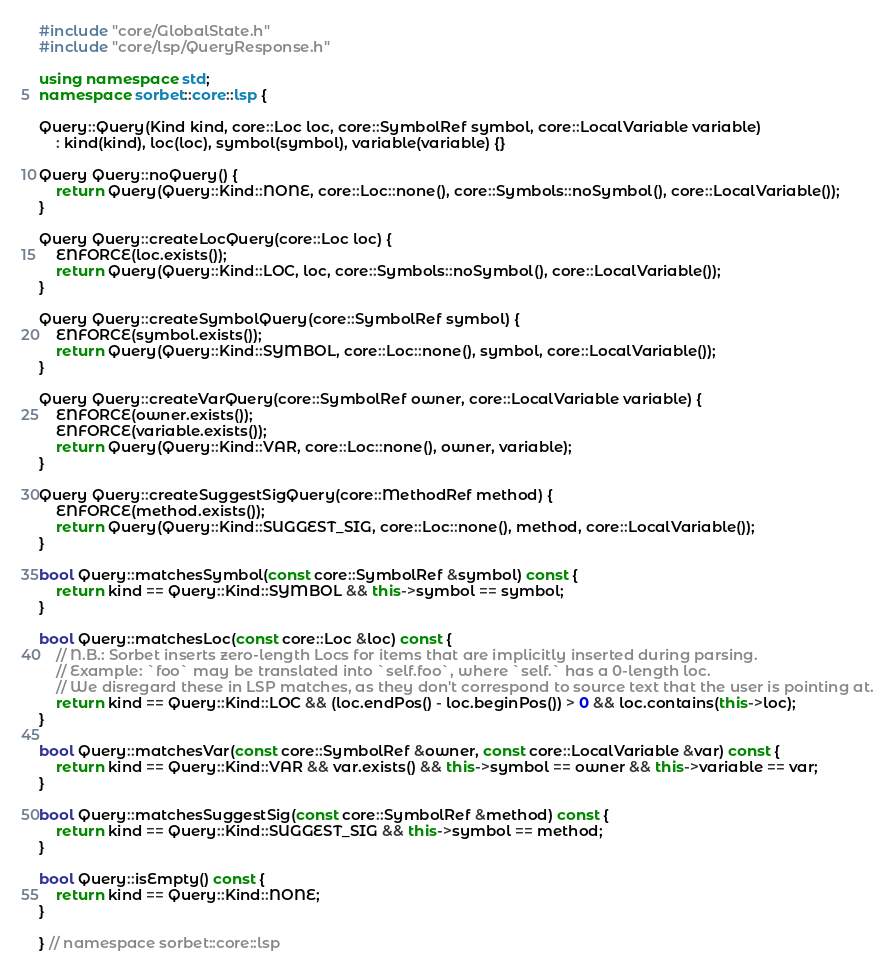Convert code to text. <code><loc_0><loc_0><loc_500><loc_500><_C++_>#include "core/GlobalState.h"
#include "core/lsp/QueryResponse.h"

using namespace std;
namespace sorbet::core::lsp {

Query::Query(Kind kind, core::Loc loc, core::SymbolRef symbol, core::LocalVariable variable)
    : kind(kind), loc(loc), symbol(symbol), variable(variable) {}

Query Query::noQuery() {
    return Query(Query::Kind::NONE, core::Loc::none(), core::Symbols::noSymbol(), core::LocalVariable());
}

Query Query::createLocQuery(core::Loc loc) {
    ENFORCE(loc.exists());
    return Query(Query::Kind::LOC, loc, core::Symbols::noSymbol(), core::LocalVariable());
}

Query Query::createSymbolQuery(core::SymbolRef symbol) {
    ENFORCE(symbol.exists());
    return Query(Query::Kind::SYMBOL, core::Loc::none(), symbol, core::LocalVariable());
}

Query Query::createVarQuery(core::SymbolRef owner, core::LocalVariable variable) {
    ENFORCE(owner.exists());
    ENFORCE(variable.exists());
    return Query(Query::Kind::VAR, core::Loc::none(), owner, variable);
}

Query Query::createSuggestSigQuery(core::MethodRef method) {
    ENFORCE(method.exists());
    return Query(Query::Kind::SUGGEST_SIG, core::Loc::none(), method, core::LocalVariable());
}

bool Query::matchesSymbol(const core::SymbolRef &symbol) const {
    return kind == Query::Kind::SYMBOL && this->symbol == symbol;
}

bool Query::matchesLoc(const core::Loc &loc) const {
    // N.B.: Sorbet inserts zero-length Locs for items that are implicitly inserted during parsing.
    // Example: `foo` may be translated into `self.foo`, where `self.` has a 0-length loc.
    // We disregard these in LSP matches, as they don't correspond to source text that the user is pointing at.
    return kind == Query::Kind::LOC && (loc.endPos() - loc.beginPos()) > 0 && loc.contains(this->loc);
}

bool Query::matchesVar(const core::SymbolRef &owner, const core::LocalVariable &var) const {
    return kind == Query::Kind::VAR && var.exists() && this->symbol == owner && this->variable == var;
}

bool Query::matchesSuggestSig(const core::SymbolRef &method) const {
    return kind == Query::Kind::SUGGEST_SIG && this->symbol == method;
}

bool Query::isEmpty() const {
    return kind == Query::Kind::NONE;
}

} // namespace sorbet::core::lsp
</code> 